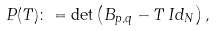Convert formula to latex. <formula><loc_0><loc_0><loc_500><loc_500>P ( T ) \colon = \det \left ( B _ { p , q } - T \, I d _ { N } \right ) ,</formula> 